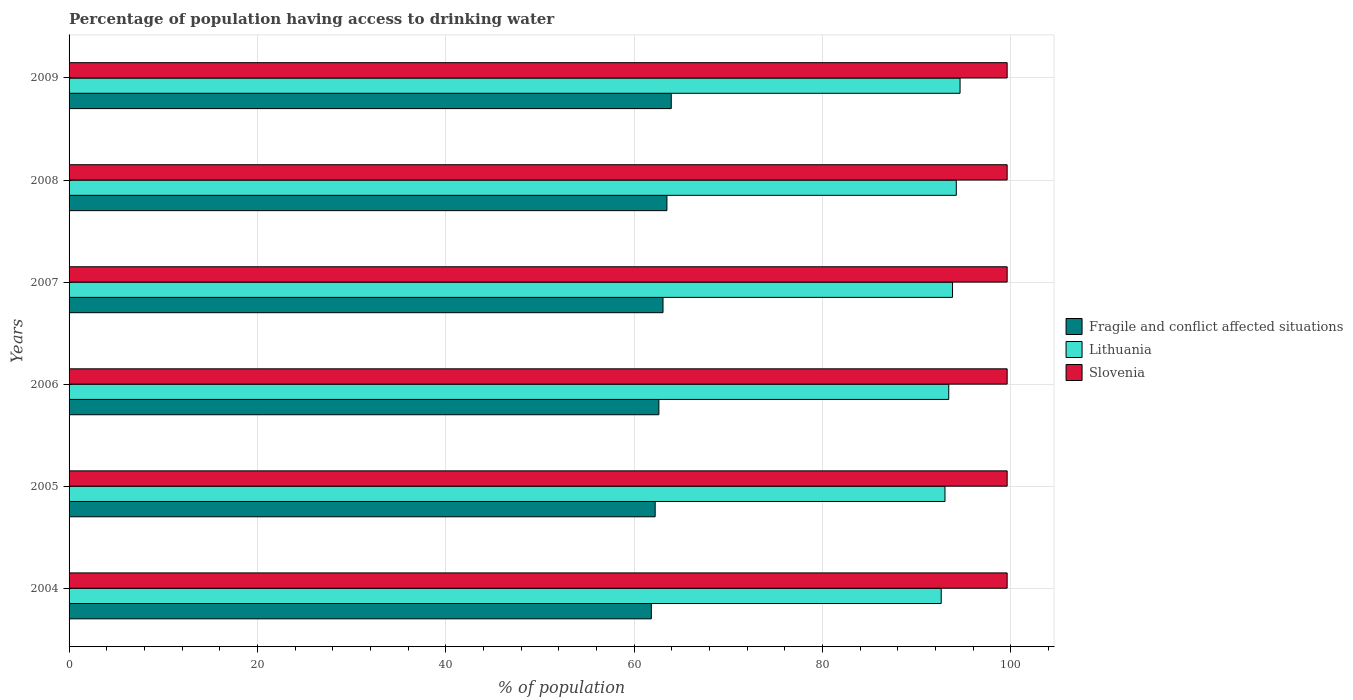How many groups of bars are there?
Provide a succinct answer. 6. Are the number of bars per tick equal to the number of legend labels?
Provide a short and direct response. Yes. Are the number of bars on each tick of the Y-axis equal?
Your response must be concise. Yes. What is the percentage of population having access to drinking water in Fragile and conflict affected situations in 2009?
Ensure brevity in your answer.  63.94. Across all years, what is the maximum percentage of population having access to drinking water in Slovenia?
Offer a very short reply. 99.6. Across all years, what is the minimum percentage of population having access to drinking water in Lithuania?
Provide a short and direct response. 92.6. In which year was the percentage of population having access to drinking water in Fragile and conflict affected situations minimum?
Make the answer very short. 2004. What is the total percentage of population having access to drinking water in Fragile and conflict affected situations in the graph?
Your answer should be compact. 377.15. What is the difference between the percentage of population having access to drinking water in Lithuania in 2004 and that in 2007?
Make the answer very short. -1.2. What is the difference between the percentage of population having access to drinking water in Fragile and conflict affected situations in 2008 and the percentage of population having access to drinking water in Slovenia in 2007?
Your answer should be very brief. -36.12. What is the average percentage of population having access to drinking water in Slovenia per year?
Keep it short and to the point. 99.6. In the year 2007, what is the difference between the percentage of population having access to drinking water in Slovenia and percentage of population having access to drinking water in Lithuania?
Ensure brevity in your answer.  5.8. What is the ratio of the percentage of population having access to drinking water in Fragile and conflict affected situations in 2006 to that in 2009?
Provide a succinct answer. 0.98. What is the difference between the highest and the second highest percentage of population having access to drinking water in Fragile and conflict affected situations?
Ensure brevity in your answer.  0.46. What is the difference between the highest and the lowest percentage of population having access to drinking water in Fragile and conflict affected situations?
Give a very brief answer. 2.11. What does the 2nd bar from the top in 2008 represents?
Keep it short and to the point. Lithuania. What does the 1st bar from the bottom in 2009 represents?
Offer a very short reply. Fragile and conflict affected situations. Is it the case that in every year, the sum of the percentage of population having access to drinking water in Lithuania and percentage of population having access to drinking water in Fragile and conflict affected situations is greater than the percentage of population having access to drinking water in Slovenia?
Your answer should be very brief. Yes. What is the difference between two consecutive major ticks on the X-axis?
Offer a terse response. 20. Does the graph contain any zero values?
Offer a terse response. No. Does the graph contain grids?
Keep it short and to the point. Yes. Where does the legend appear in the graph?
Your answer should be very brief. Center right. What is the title of the graph?
Your answer should be very brief. Percentage of population having access to drinking water. Does "Israel" appear as one of the legend labels in the graph?
Make the answer very short. No. What is the label or title of the X-axis?
Give a very brief answer. % of population. What is the % of population in Fragile and conflict affected situations in 2004?
Offer a terse response. 61.82. What is the % of population in Lithuania in 2004?
Your answer should be compact. 92.6. What is the % of population in Slovenia in 2004?
Your answer should be very brief. 99.6. What is the % of population in Fragile and conflict affected situations in 2005?
Ensure brevity in your answer.  62.23. What is the % of population in Lithuania in 2005?
Ensure brevity in your answer.  93. What is the % of population of Slovenia in 2005?
Provide a succinct answer. 99.6. What is the % of population of Fragile and conflict affected situations in 2006?
Ensure brevity in your answer.  62.62. What is the % of population of Lithuania in 2006?
Your answer should be very brief. 93.4. What is the % of population of Slovenia in 2006?
Offer a very short reply. 99.6. What is the % of population in Fragile and conflict affected situations in 2007?
Make the answer very short. 63.06. What is the % of population in Lithuania in 2007?
Ensure brevity in your answer.  93.8. What is the % of population in Slovenia in 2007?
Provide a short and direct response. 99.6. What is the % of population in Fragile and conflict affected situations in 2008?
Give a very brief answer. 63.48. What is the % of population in Lithuania in 2008?
Provide a succinct answer. 94.2. What is the % of population of Slovenia in 2008?
Keep it short and to the point. 99.6. What is the % of population in Fragile and conflict affected situations in 2009?
Offer a very short reply. 63.94. What is the % of population of Lithuania in 2009?
Your answer should be compact. 94.6. What is the % of population in Slovenia in 2009?
Make the answer very short. 99.6. Across all years, what is the maximum % of population in Fragile and conflict affected situations?
Your answer should be very brief. 63.94. Across all years, what is the maximum % of population of Lithuania?
Provide a short and direct response. 94.6. Across all years, what is the maximum % of population in Slovenia?
Give a very brief answer. 99.6. Across all years, what is the minimum % of population in Fragile and conflict affected situations?
Your answer should be very brief. 61.82. Across all years, what is the minimum % of population in Lithuania?
Make the answer very short. 92.6. Across all years, what is the minimum % of population of Slovenia?
Give a very brief answer. 99.6. What is the total % of population in Fragile and conflict affected situations in the graph?
Keep it short and to the point. 377.15. What is the total % of population of Lithuania in the graph?
Give a very brief answer. 561.6. What is the total % of population in Slovenia in the graph?
Your response must be concise. 597.6. What is the difference between the % of population of Fragile and conflict affected situations in 2004 and that in 2005?
Offer a very short reply. -0.41. What is the difference between the % of population in Fragile and conflict affected situations in 2004 and that in 2006?
Make the answer very short. -0.8. What is the difference between the % of population in Slovenia in 2004 and that in 2006?
Keep it short and to the point. 0. What is the difference between the % of population in Fragile and conflict affected situations in 2004 and that in 2007?
Ensure brevity in your answer.  -1.24. What is the difference between the % of population in Lithuania in 2004 and that in 2007?
Offer a very short reply. -1.2. What is the difference between the % of population of Fragile and conflict affected situations in 2004 and that in 2008?
Give a very brief answer. -1.65. What is the difference between the % of population in Lithuania in 2004 and that in 2008?
Provide a short and direct response. -1.6. What is the difference between the % of population of Slovenia in 2004 and that in 2008?
Your response must be concise. 0. What is the difference between the % of population in Fragile and conflict affected situations in 2004 and that in 2009?
Offer a very short reply. -2.11. What is the difference between the % of population in Lithuania in 2004 and that in 2009?
Offer a very short reply. -2. What is the difference between the % of population in Fragile and conflict affected situations in 2005 and that in 2006?
Make the answer very short. -0.39. What is the difference between the % of population in Lithuania in 2005 and that in 2006?
Offer a very short reply. -0.4. What is the difference between the % of population in Fragile and conflict affected situations in 2005 and that in 2007?
Provide a short and direct response. -0.83. What is the difference between the % of population in Lithuania in 2005 and that in 2007?
Give a very brief answer. -0.8. What is the difference between the % of population of Slovenia in 2005 and that in 2007?
Your response must be concise. 0. What is the difference between the % of population in Fragile and conflict affected situations in 2005 and that in 2008?
Your answer should be compact. -1.25. What is the difference between the % of population in Slovenia in 2005 and that in 2008?
Make the answer very short. 0. What is the difference between the % of population in Fragile and conflict affected situations in 2005 and that in 2009?
Keep it short and to the point. -1.71. What is the difference between the % of population in Fragile and conflict affected situations in 2006 and that in 2007?
Offer a very short reply. -0.44. What is the difference between the % of population in Lithuania in 2006 and that in 2007?
Your answer should be compact. -0.4. What is the difference between the % of population in Slovenia in 2006 and that in 2007?
Offer a very short reply. 0. What is the difference between the % of population of Fragile and conflict affected situations in 2006 and that in 2008?
Give a very brief answer. -0.85. What is the difference between the % of population of Fragile and conflict affected situations in 2006 and that in 2009?
Offer a very short reply. -1.32. What is the difference between the % of population of Lithuania in 2006 and that in 2009?
Provide a short and direct response. -1.2. What is the difference between the % of population of Fragile and conflict affected situations in 2007 and that in 2008?
Your answer should be compact. -0.42. What is the difference between the % of population of Slovenia in 2007 and that in 2008?
Offer a very short reply. 0. What is the difference between the % of population in Fragile and conflict affected situations in 2007 and that in 2009?
Keep it short and to the point. -0.88. What is the difference between the % of population in Slovenia in 2007 and that in 2009?
Your response must be concise. 0. What is the difference between the % of population of Fragile and conflict affected situations in 2008 and that in 2009?
Ensure brevity in your answer.  -0.46. What is the difference between the % of population in Lithuania in 2008 and that in 2009?
Ensure brevity in your answer.  -0.4. What is the difference between the % of population of Slovenia in 2008 and that in 2009?
Offer a very short reply. 0. What is the difference between the % of population of Fragile and conflict affected situations in 2004 and the % of population of Lithuania in 2005?
Keep it short and to the point. -31.18. What is the difference between the % of population of Fragile and conflict affected situations in 2004 and the % of population of Slovenia in 2005?
Your answer should be very brief. -37.78. What is the difference between the % of population of Lithuania in 2004 and the % of population of Slovenia in 2005?
Keep it short and to the point. -7. What is the difference between the % of population of Fragile and conflict affected situations in 2004 and the % of population of Lithuania in 2006?
Provide a succinct answer. -31.58. What is the difference between the % of population of Fragile and conflict affected situations in 2004 and the % of population of Slovenia in 2006?
Offer a terse response. -37.78. What is the difference between the % of population in Lithuania in 2004 and the % of population in Slovenia in 2006?
Ensure brevity in your answer.  -7. What is the difference between the % of population of Fragile and conflict affected situations in 2004 and the % of population of Lithuania in 2007?
Provide a succinct answer. -31.98. What is the difference between the % of population of Fragile and conflict affected situations in 2004 and the % of population of Slovenia in 2007?
Offer a very short reply. -37.78. What is the difference between the % of population in Lithuania in 2004 and the % of population in Slovenia in 2007?
Provide a succinct answer. -7. What is the difference between the % of population of Fragile and conflict affected situations in 2004 and the % of population of Lithuania in 2008?
Ensure brevity in your answer.  -32.38. What is the difference between the % of population of Fragile and conflict affected situations in 2004 and the % of population of Slovenia in 2008?
Keep it short and to the point. -37.78. What is the difference between the % of population of Fragile and conflict affected situations in 2004 and the % of population of Lithuania in 2009?
Offer a terse response. -32.78. What is the difference between the % of population in Fragile and conflict affected situations in 2004 and the % of population in Slovenia in 2009?
Provide a short and direct response. -37.78. What is the difference between the % of population of Fragile and conflict affected situations in 2005 and the % of population of Lithuania in 2006?
Keep it short and to the point. -31.17. What is the difference between the % of population of Fragile and conflict affected situations in 2005 and the % of population of Slovenia in 2006?
Keep it short and to the point. -37.37. What is the difference between the % of population in Fragile and conflict affected situations in 2005 and the % of population in Lithuania in 2007?
Your answer should be compact. -31.57. What is the difference between the % of population of Fragile and conflict affected situations in 2005 and the % of population of Slovenia in 2007?
Keep it short and to the point. -37.37. What is the difference between the % of population in Fragile and conflict affected situations in 2005 and the % of population in Lithuania in 2008?
Offer a very short reply. -31.97. What is the difference between the % of population of Fragile and conflict affected situations in 2005 and the % of population of Slovenia in 2008?
Provide a short and direct response. -37.37. What is the difference between the % of population of Fragile and conflict affected situations in 2005 and the % of population of Lithuania in 2009?
Your answer should be compact. -32.37. What is the difference between the % of population of Fragile and conflict affected situations in 2005 and the % of population of Slovenia in 2009?
Give a very brief answer. -37.37. What is the difference between the % of population in Fragile and conflict affected situations in 2006 and the % of population in Lithuania in 2007?
Ensure brevity in your answer.  -31.18. What is the difference between the % of population of Fragile and conflict affected situations in 2006 and the % of population of Slovenia in 2007?
Ensure brevity in your answer.  -36.98. What is the difference between the % of population in Lithuania in 2006 and the % of population in Slovenia in 2007?
Offer a very short reply. -6.2. What is the difference between the % of population of Fragile and conflict affected situations in 2006 and the % of population of Lithuania in 2008?
Your answer should be very brief. -31.58. What is the difference between the % of population of Fragile and conflict affected situations in 2006 and the % of population of Slovenia in 2008?
Your response must be concise. -36.98. What is the difference between the % of population of Fragile and conflict affected situations in 2006 and the % of population of Lithuania in 2009?
Provide a succinct answer. -31.98. What is the difference between the % of population in Fragile and conflict affected situations in 2006 and the % of population in Slovenia in 2009?
Provide a succinct answer. -36.98. What is the difference between the % of population in Lithuania in 2006 and the % of population in Slovenia in 2009?
Your answer should be compact. -6.2. What is the difference between the % of population in Fragile and conflict affected situations in 2007 and the % of population in Lithuania in 2008?
Your response must be concise. -31.14. What is the difference between the % of population of Fragile and conflict affected situations in 2007 and the % of population of Slovenia in 2008?
Make the answer very short. -36.54. What is the difference between the % of population in Fragile and conflict affected situations in 2007 and the % of population in Lithuania in 2009?
Give a very brief answer. -31.54. What is the difference between the % of population of Fragile and conflict affected situations in 2007 and the % of population of Slovenia in 2009?
Provide a short and direct response. -36.54. What is the difference between the % of population of Fragile and conflict affected situations in 2008 and the % of population of Lithuania in 2009?
Ensure brevity in your answer.  -31.12. What is the difference between the % of population in Fragile and conflict affected situations in 2008 and the % of population in Slovenia in 2009?
Ensure brevity in your answer.  -36.12. What is the average % of population in Fragile and conflict affected situations per year?
Ensure brevity in your answer.  62.86. What is the average % of population of Lithuania per year?
Your answer should be compact. 93.6. What is the average % of population of Slovenia per year?
Provide a short and direct response. 99.6. In the year 2004, what is the difference between the % of population in Fragile and conflict affected situations and % of population in Lithuania?
Your response must be concise. -30.78. In the year 2004, what is the difference between the % of population in Fragile and conflict affected situations and % of population in Slovenia?
Ensure brevity in your answer.  -37.78. In the year 2004, what is the difference between the % of population in Lithuania and % of population in Slovenia?
Your response must be concise. -7. In the year 2005, what is the difference between the % of population in Fragile and conflict affected situations and % of population in Lithuania?
Your answer should be very brief. -30.77. In the year 2005, what is the difference between the % of population in Fragile and conflict affected situations and % of population in Slovenia?
Your answer should be very brief. -37.37. In the year 2006, what is the difference between the % of population of Fragile and conflict affected situations and % of population of Lithuania?
Ensure brevity in your answer.  -30.78. In the year 2006, what is the difference between the % of population of Fragile and conflict affected situations and % of population of Slovenia?
Your answer should be compact. -36.98. In the year 2006, what is the difference between the % of population in Lithuania and % of population in Slovenia?
Offer a terse response. -6.2. In the year 2007, what is the difference between the % of population in Fragile and conflict affected situations and % of population in Lithuania?
Your answer should be very brief. -30.74. In the year 2007, what is the difference between the % of population of Fragile and conflict affected situations and % of population of Slovenia?
Provide a succinct answer. -36.54. In the year 2007, what is the difference between the % of population in Lithuania and % of population in Slovenia?
Provide a succinct answer. -5.8. In the year 2008, what is the difference between the % of population of Fragile and conflict affected situations and % of population of Lithuania?
Provide a succinct answer. -30.72. In the year 2008, what is the difference between the % of population of Fragile and conflict affected situations and % of population of Slovenia?
Provide a short and direct response. -36.12. In the year 2009, what is the difference between the % of population in Fragile and conflict affected situations and % of population in Lithuania?
Keep it short and to the point. -30.66. In the year 2009, what is the difference between the % of population in Fragile and conflict affected situations and % of population in Slovenia?
Your answer should be very brief. -35.66. In the year 2009, what is the difference between the % of population of Lithuania and % of population of Slovenia?
Ensure brevity in your answer.  -5. What is the ratio of the % of population of Fragile and conflict affected situations in 2004 to that in 2006?
Your answer should be compact. 0.99. What is the ratio of the % of population of Slovenia in 2004 to that in 2006?
Ensure brevity in your answer.  1. What is the ratio of the % of population of Fragile and conflict affected situations in 2004 to that in 2007?
Ensure brevity in your answer.  0.98. What is the ratio of the % of population in Lithuania in 2004 to that in 2007?
Your answer should be compact. 0.99. What is the ratio of the % of population of Fragile and conflict affected situations in 2004 to that in 2008?
Offer a very short reply. 0.97. What is the ratio of the % of population of Lithuania in 2004 to that in 2008?
Provide a short and direct response. 0.98. What is the ratio of the % of population in Slovenia in 2004 to that in 2008?
Ensure brevity in your answer.  1. What is the ratio of the % of population in Fragile and conflict affected situations in 2004 to that in 2009?
Your answer should be compact. 0.97. What is the ratio of the % of population in Lithuania in 2004 to that in 2009?
Offer a very short reply. 0.98. What is the ratio of the % of population of Lithuania in 2005 to that in 2007?
Your answer should be very brief. 0.99. What is the ratio of the % of population in Fragile and conflict affected situations in 2005 to that in 2008?
Give a very brief answer. 0.98. What is the ratio of the % of population in Lithuania in 2005 to that in 2008?
Make the answer very short. 0.99. What is the ratio of the % of population of Slovenia in 2005 to that in 2008?
Give a very brief answer. 1. What is the ratio of the % of population of Fragile and conflict affected situations in 2005 to that in 2009?
Offer a very short reply. 0.97. What is the ratio of the % of population of Lithuania in 2005 to that in 2009?
Your answer should be compact. 0.98. What is the ratio of the % of population of Slovenia in 2005 to that in 2009?
Offer a terse response. 1. What is the ratio of the % of population of Fragile and conflict affected situations in 2006 to that in 2008?
Give a very brief answer. 0.99. What is the ratio of the % of population in Lithuania in 2006 to that in 2008?
Offer a terse response. 0.99. What is the ratio of the % of population of Slovenia in 2006 to that in 2008?
Offer a very short reply. 1. What is the ratio of the % of population of Fragile and conflict affected situations in 2006 to that in 2009?
Offer a very short reply. 0.98. What is the ratio of the % of population of Lithuania in 2006 to that in 2009?
Give a very brief answer. 0.99. What is the ratio of the % of population of Slovenia in 2006 to that in 2009?
Offer a terse response. 1. What is the ratio of the % of population in Fragile and conflict affected situations in 2007 to that in 2008?
Offer a very short reply. 0.99. What is the ratio of the % of population of Lithuania in 2007 to that in 2008?
Your answer should be compact. 1. What is the ratio of the % of population of Slovenia in 2007 to that in 2008?
Ensure brevity in your answer.  1. What is the ratio of the % of population of Fragile and conflict affected situations in 2007 to that in 2009?
Your answer should be compact. 0.99. What is the ratio of the % of population in Lithuania in 2007 to that in 2009?
Keep it short and to the point. 0.99. What is the ratio of the % of population in Lithuania in 2008 to that in 2009?
Ensure brevity in your answer.  1. What is the ratio of the % of population in Slovenia in 2008 to that in 2009?
Make the answer very short. 1. What is the difference between the highest and the second highest % of population of Fragile and conflict affected situations?
Offer a terse response. 0.46. What is the difference between the highest and the second highest % of population in Lithuania?
Your answer should be very brief. 0.4. What is the difference between the highest and the lowest % of population of Fragile and conflict affected situations?
Keep it short and to the point. 2.11. What is the difference between the highest and the lowest % of population of Lithuania?
Offer a very short reply. 2. 